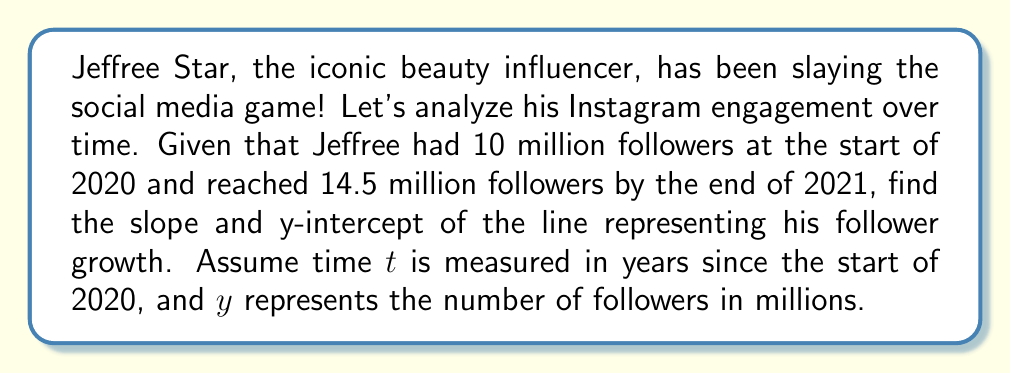Show me your answer to this math problem. To find the slope and y-intercept, we'll use the point-slope form of a line: $y - y_1 = m(t - t_1)$

We have two points:
$(t_1, y_1) = (0, 10)$ (start of 2020)
$(t_2, y_2) = (2, 14.5)$ (end of 2021, which is 2 years later)

1. Calculate the slope:
   $$m = \frac{y_2 - y_1}{t_2 - t_1} = \frac{14.5 - 10}{2 - 0} = \frac{4.5}{2} = 2.25$$

2. Use the point-slope form with $(t_1, y_1) = (0, 10)$:
   $$y - 10 = 2.25(t - 0)$$

3. Simplify to slope-intercept form $y = mt + b$:
   $$y = 2.25t + 10$$

The y-intercept is the value of $y$ when $t = 0$, which is 10 million followers.
Answer: Slope: $m = 2.25$ million followers per year
Y-intercept: $b = 10$ million followers 